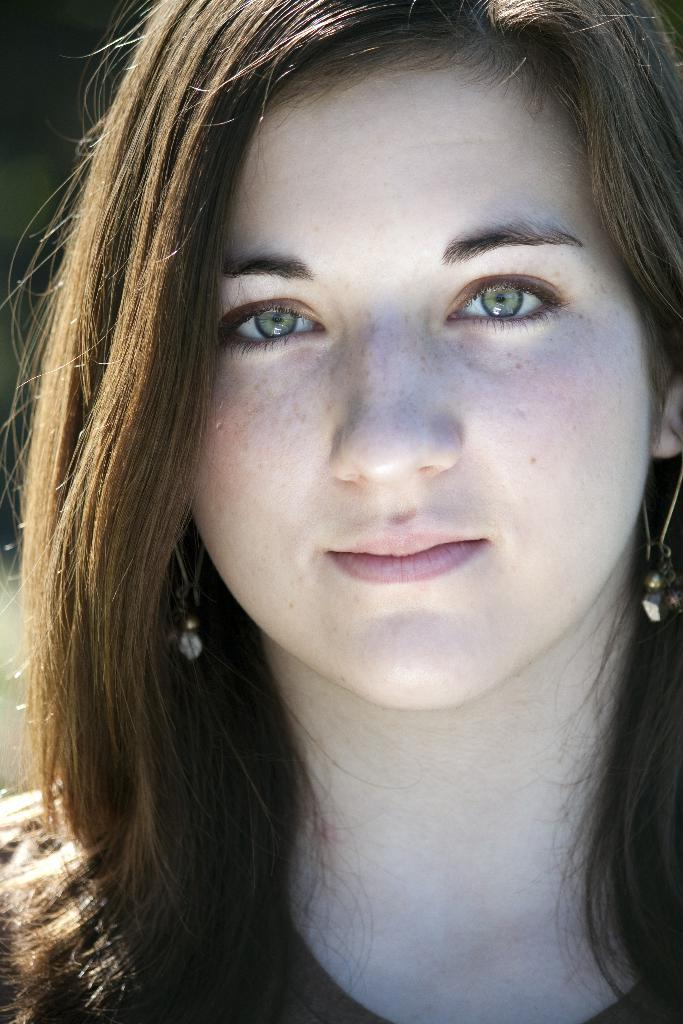Who is the main subject in the image? There is a woman in the image. What is the woman doing in the image? The woman is posing for the picture. What type of volleyball is the woman holding in the image? There is no volleyball present in the image. How many clocks can be seen on the woman's wrist in the image? There are no clocks visible on the woman's wrist in the image. 